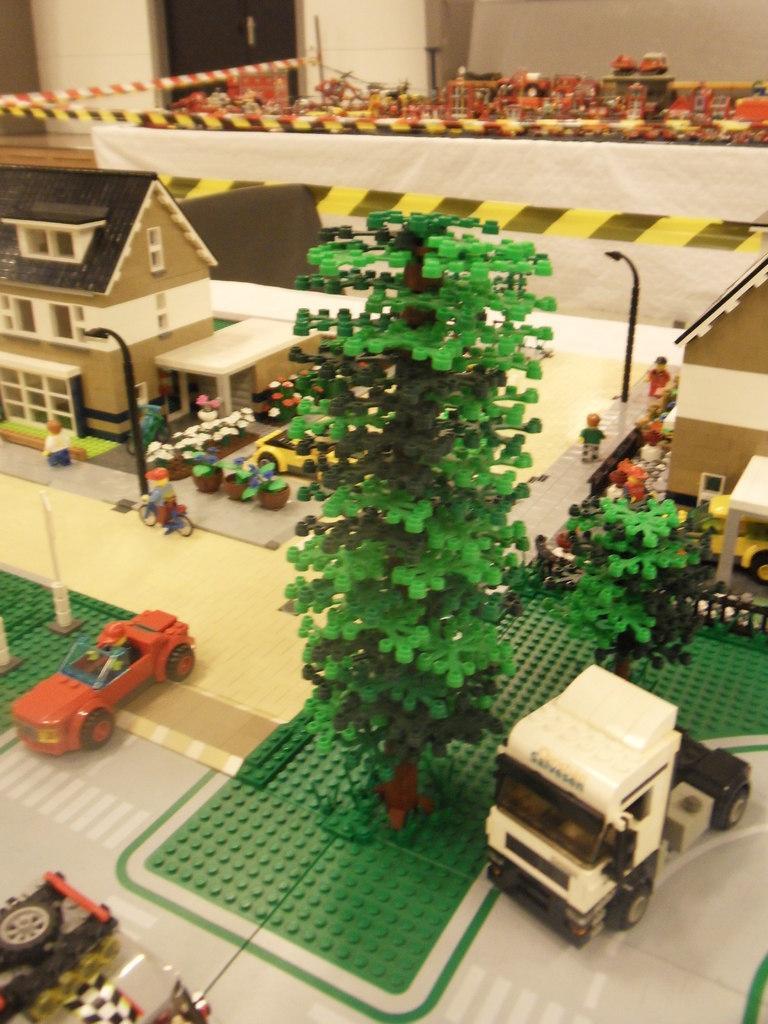Describe this image in one or two sentences. In this image I can see house, in front of house I can see flower pots, persons , bicycle , poles visible on left side and there are vehicles, pole persons, car visible in the middle ,at the top I can see the door, wall, some other objects. 